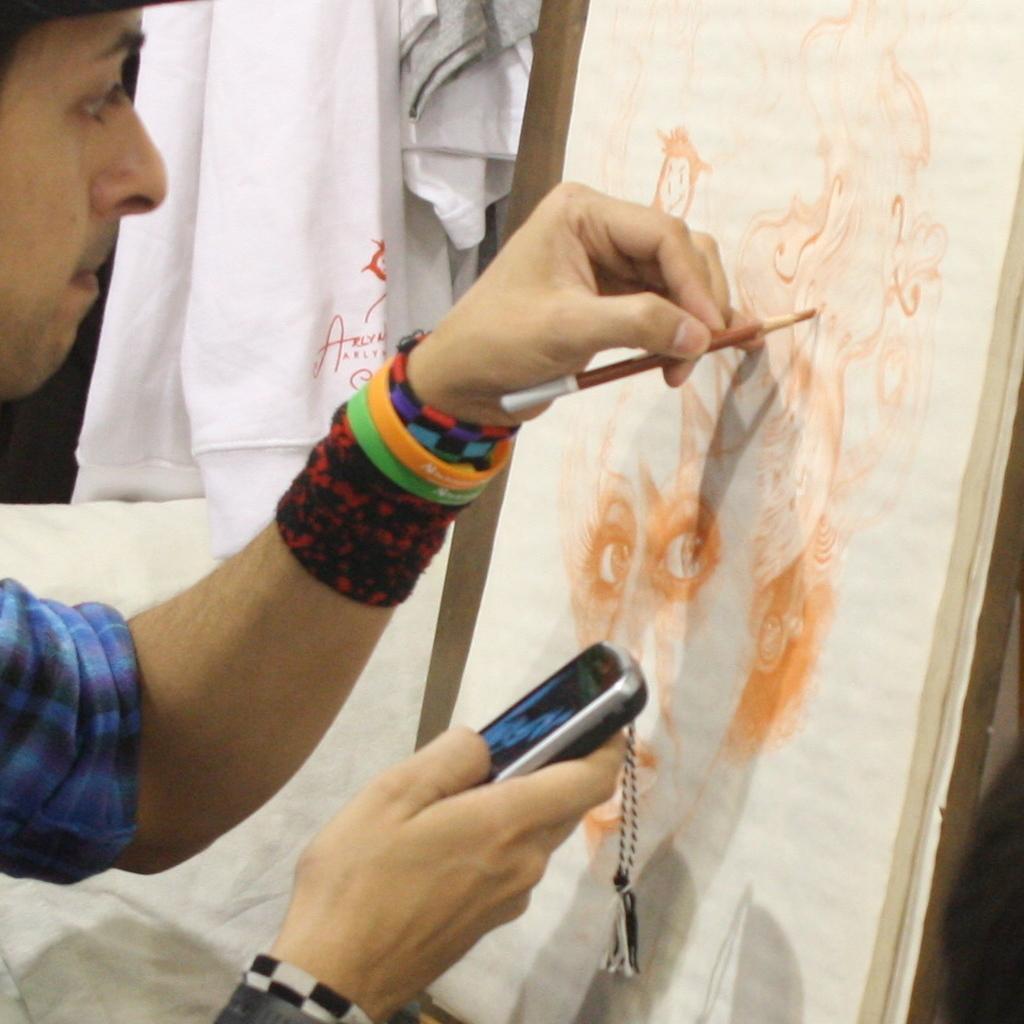Could you give a brief overview of what you see in this image? In this image we can see a person painting on a paper, in his hand, we can see a mobile, and a pencil, there is a board, and clothes. 